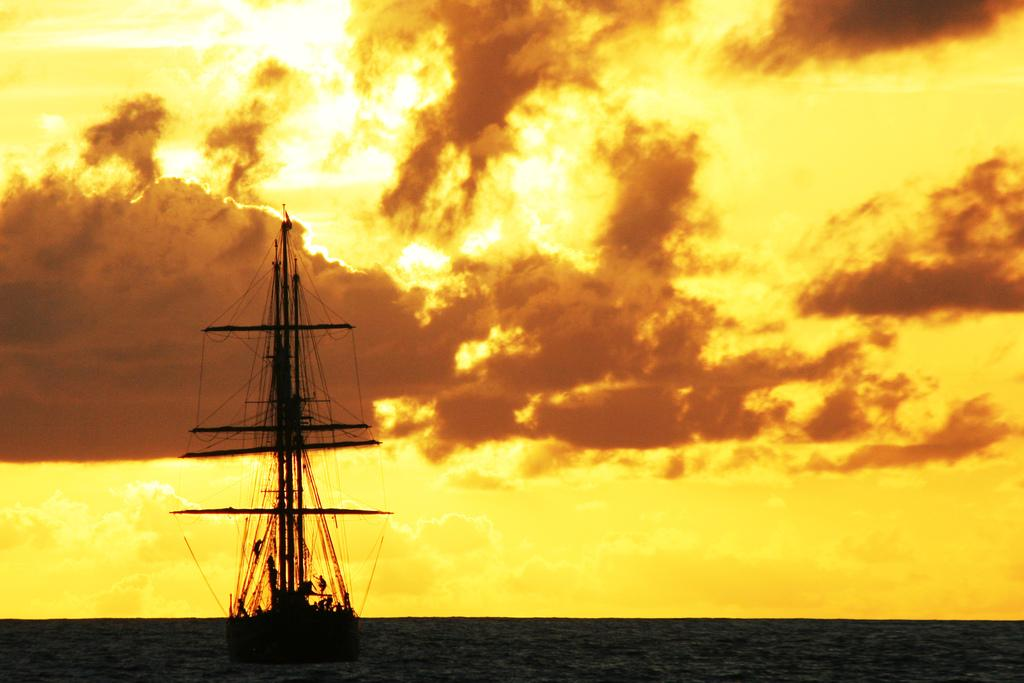What is the main subject of the image? The main subject of the image is a boat. Where is the boat located? The boat is on the water. What can be seen in the background of the image? The sky is visible in the background of the image. Can you see any signs of industry in the image? There is no indication of industry present in the image; it features a boat on the water with a visible sky in the background. Is there a tiger visible in the image? No, there is no tiger present in the image. 